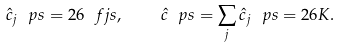<formula> <loc_0><loc_0><loc_500><loc_500>\hat { c } _ { j } \ p s = 2 6 \ f j s , \quad \hat { c } \ p s = \sum _ { j } \hat { c } _ { j } \ p s = 2 6 K .</formula> 